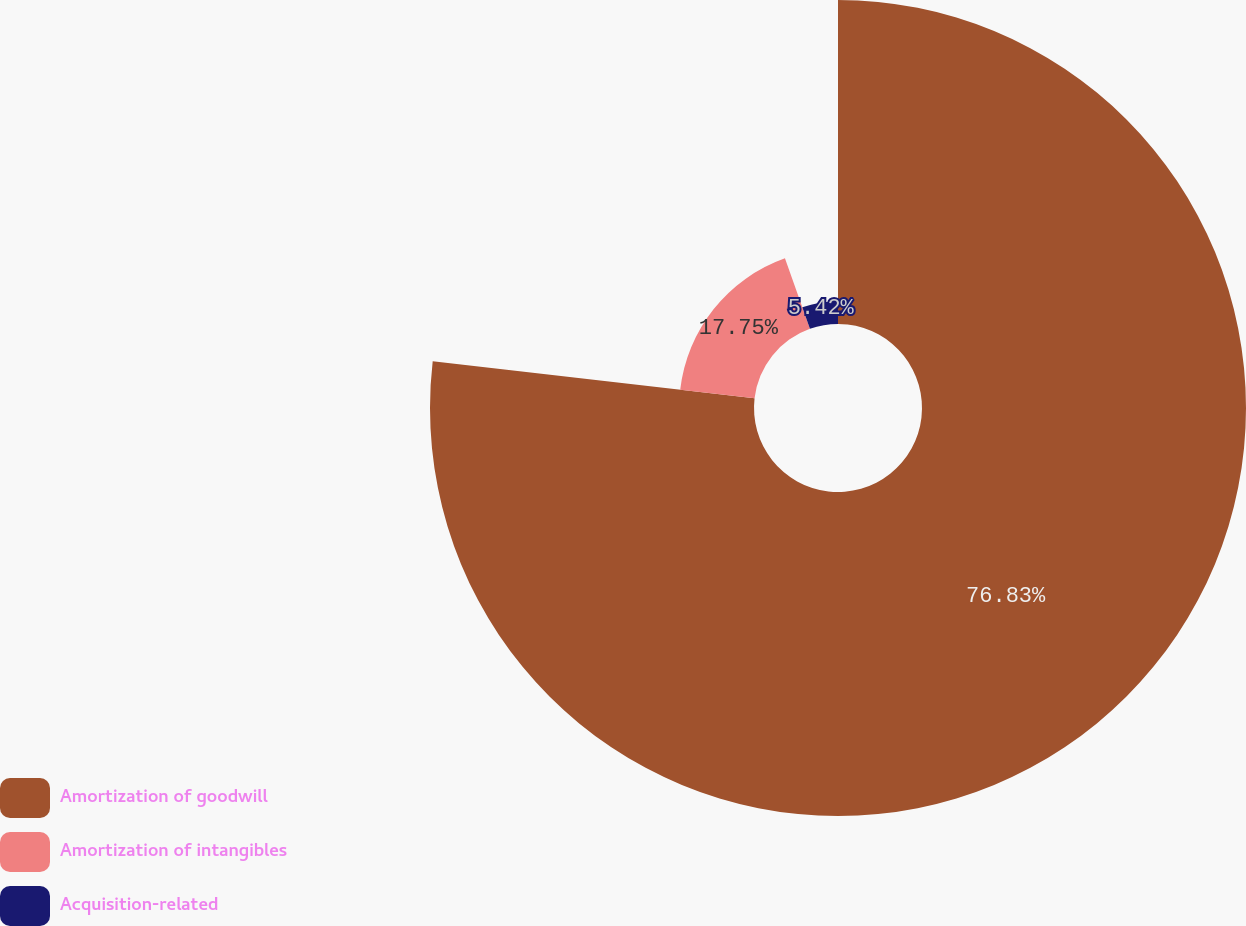Convert chart to OTSL. <chart><loc_0><loc_0><loc_500><loc_500><pie_chart><fcel>Amortization of goodwill<fcel>Amortization of intangibles<fcel>Acquisition-related<nl><fcel>76.83%<fcel>17.75%<fcel>5.42%<nl></chart> 